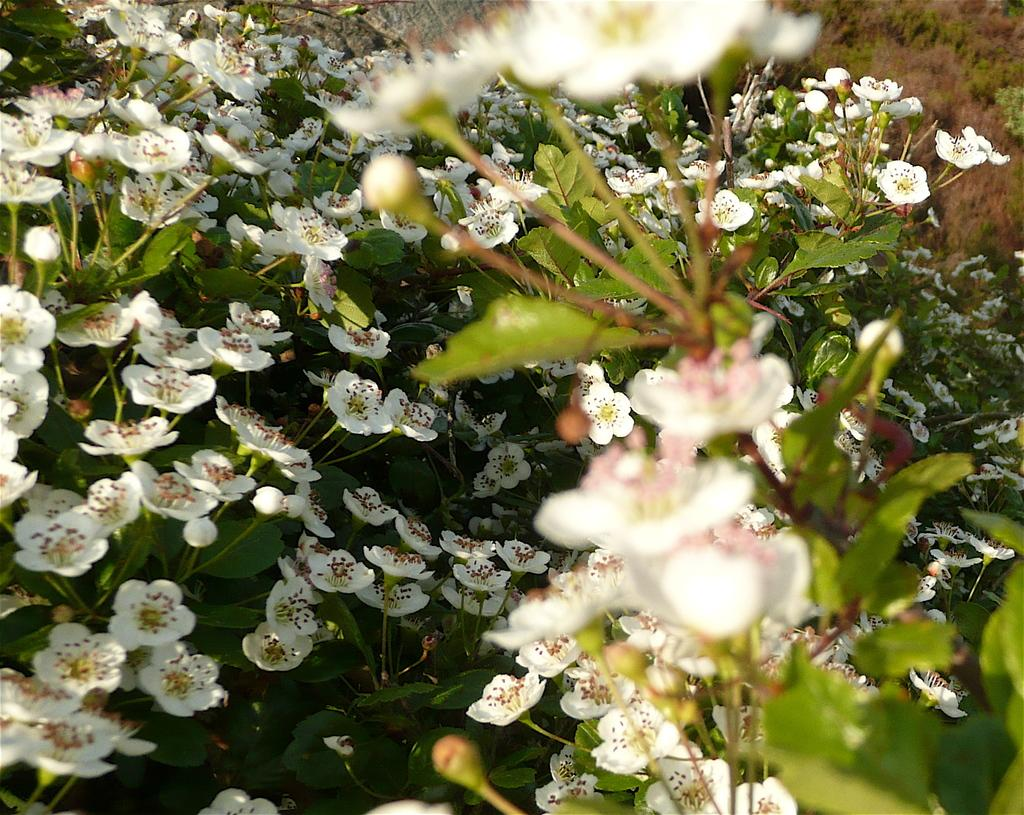What type of flowers are on the plant in the image? There are white flowers on top of the plant in the image. Can you describe the plant's appearance? Unfortunately, the provided facts do not give any information about the plant's appearance, only the flowers. What is the person's fear in the image? There is no person or fear mentioned in the image; it only features white flowers on a plant. 